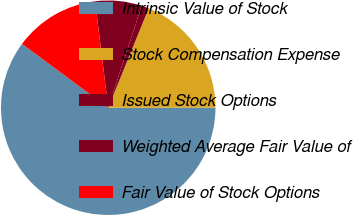<chart> <loc_0><loc_0><loc_500><loc_500><pie_chart><fcel>Intrinsic Value of Stock<fcel>Stock Compensation Expense<fcel>Issued Stock Options<fcel>Weighted Average Fair Value of<fcel>Fair Value of Stock Options<nl><fcel>60.17%<fcel>18.82%<fcel>1.1%<fcel>7.0%<fcel>12.91%<nl></chart> 